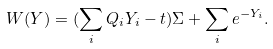<formula> <loc_0><loc_0><loc_500><loc_500>W ( Y ) = ( \sum _ { i } Q _ { i } Y _ { i } - t ) \Sigma + \sum _ { i } e ^ { - Y _ { i } } .</formula> 